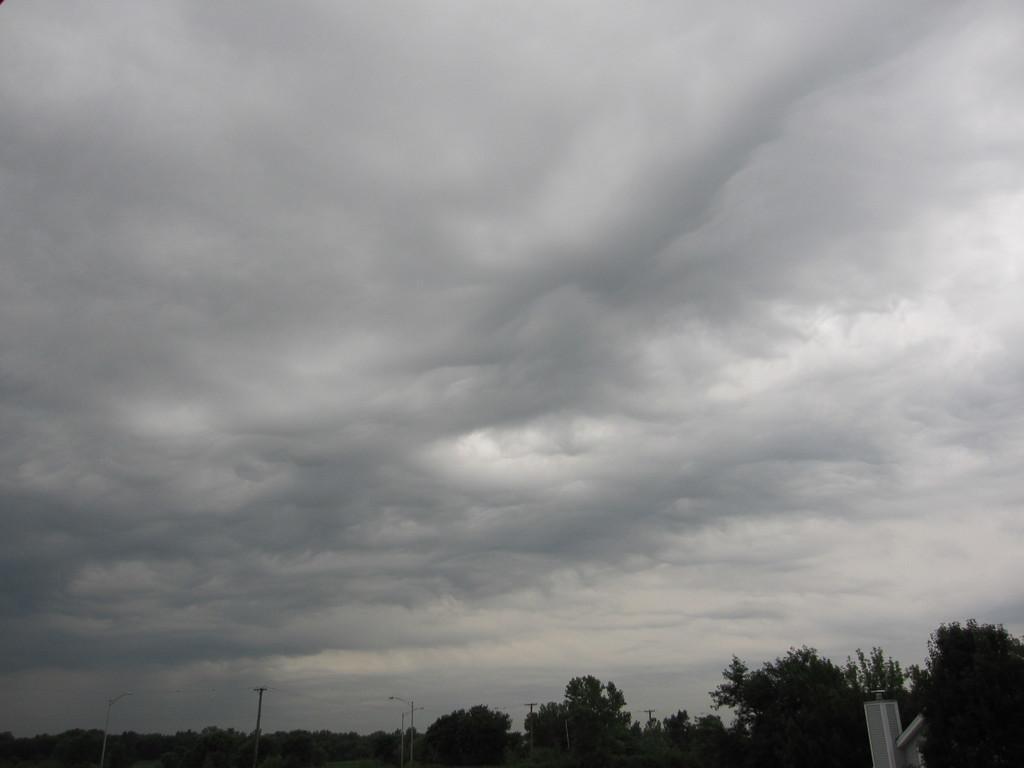How would you summarize this image in a sentence or two? In this image I can see at the bottom there are trees, at the top it is the cloudy sky. 